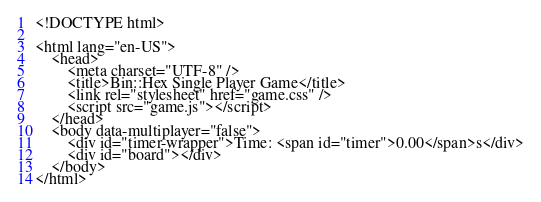Convert code to text. <code><loc_0><loc_0><loc_500><loc_500><_PHP_><!DOCTYPE html>

<html lang="en-US">
    <head>
        <meta charset="UTF-8" />
        <title>Bin::Hex Single Player Game</title>
        <link rel="stylesheet" href="game.css" />
        <script src="game.js"></script>
    </head>
    <body data-multiplayer="false">
        <div id="timer-wrapper">Time: <span id="timer">0.00</span>s</div>
        <div id="board"></div>
    </body>
</html></code> 